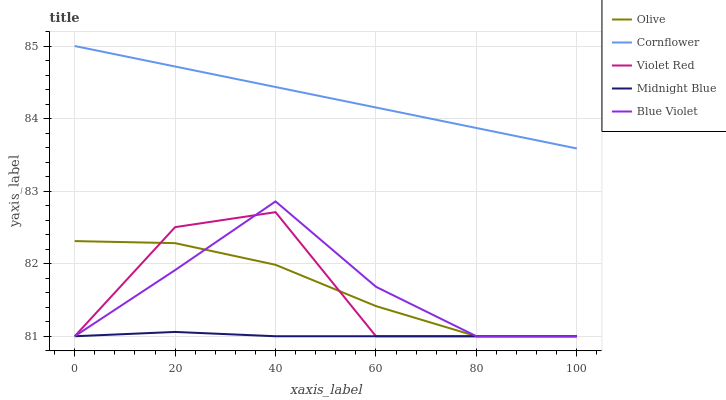Does Midnight Blue have the minimum area under the curve?
Answer yes or no. Yes. Does Cornflower have the maximum area under the curve?
Answer yes or no. Yes. Does Violet Red have the minimum area under the curve?
Answer yes or no. No. Does Violet Red have the maximum area under the curve?
Answer yes or no. No. Is Cornflower the smoothest?
Answer yes or no. Yes. Is Violet Red the roughest?
Answer yes or no. Yes. Is Violet Red the smoothest?
Answer yes or no. No. Is Cornflower the roughest?
Answer yes or no. No. Does Olive have the lowest value?
Answer yes or no. Yes. Does Cornflower have the lowest value?
Answer yes or no. No. Does Cornflower have the highest value?
Answer yes or no. Yes. Does Violet Red have the highest value?
Answer yes or no. No. Is Violet Red less than Cornflower?
Answer yes or no. Yes. Is Cornflower greater than Midnight Blue?
Answer yes or no. Yes. Does Midnight Blue intersect Violet Red?
Answer yes or no. Yes. Is Midnight Blue less than Violet Red?
Answer yes or no. No. Is Midnight Blue greater than Violet Red?
Answer yes or no. No. Does Violet Red intersect Cornflower?
Answer yes or no. No. 